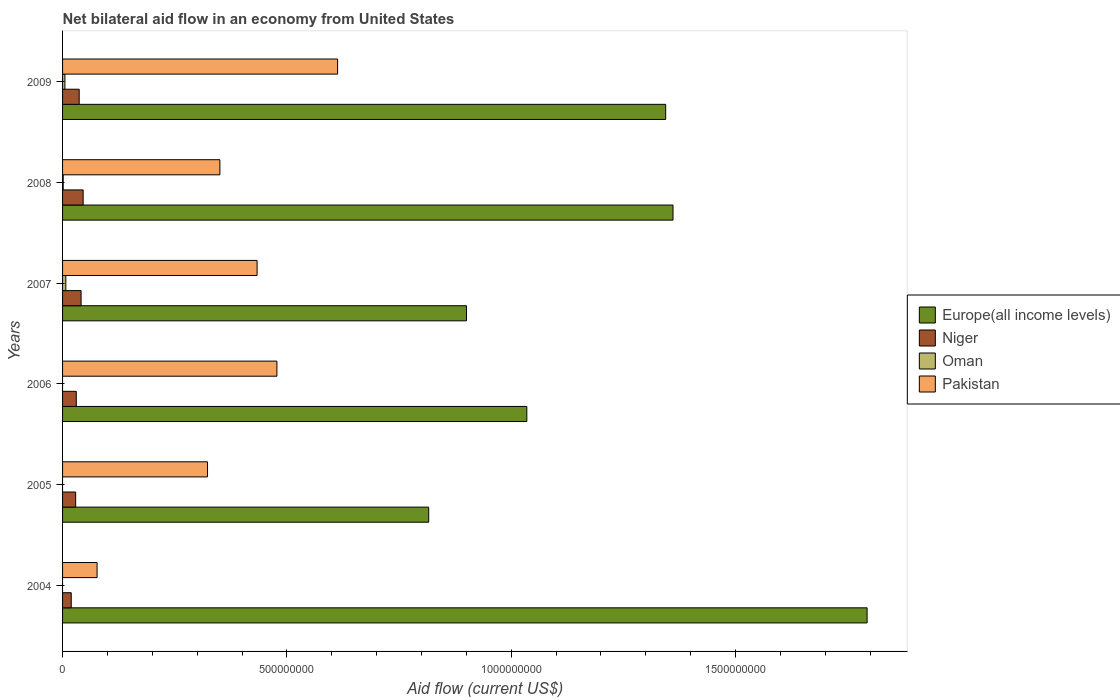How many different coloured bars are there?
Give a very brief answer. 4. How many groups of bars are there?
Provide a succinct answer. 6. Are the number of bars per tick equal to the number of legend labels?
Ensure brevity in your answer.  No. Are the number of bars on each tick of the Y-axis equal?
Make the answer very short. No. What is the label of the 4th group of bars from the top?
Your answer should be compact. 2006. What is the net bilateral aid flow in Oman in 2005?
Offer a very short reply. 0. Across all years, what is the maximum net bilateral aid flow in Niger?
Provide a succinct answer. 4.59e+07. What is the total net bilateral aid flow in Pakistan in the graph?
Give a very brief answer. 2.27e+09. What is the difference between the net bilateral aid flow in Niger in 2006 and that in 2008?
Provide a succinct answer. -1.53e+07. What is the difference between the net bilateral aid flow in Niger in 2006 and the net bilateral aid flow in Pakistan in 2007?
Offer a terse response. -4.03e+08. What is the average net bilateral aid flow in Europe(all income levels) per year?
Make the answer very short. 1.21e+09. In the year 2009, what is the difference between the net bilateral aid flow in Oman and net bilateral aid flow in Pakistan?
Offer a very short reply. -6.08e+08. In how many years, is the net bilateral aid flow in Pakistan greater than 300000000 US$?
Your response must be concise. 5. What is the ratio of the net bilateral aid flow in Niger in 2006 to that in 2009?
Your answer should be compact. 0.82. Is the net bilateral aid flow in Pakistan in 2004 less than that in 2009?
Keep it short and to the point. Yes. Is the difference between the net bilateral aid flow in Oman in 2007 and 2009 greater than the difference between the net bilateral aid flow in Pakistan in 2007 and 2009?
Your response must be concise. Yes. What is the difference between the highest and the second highest net bilateral aid flow in Niger?
Keep it short and to the point. 4.58e+06. What is the difference between the highest and the lowest net bilateral aid flow in Oman?
Make the answer very short. 7.27e+06. Is the sum of the net bilateral aid flow in Niger in 2006 and 2007 greater than the maximum net bilateral aid flow in Europe(all income levels) across all years?
Your answer should be very brief. No. Is it the case that in every year, the sum of the net bilateral aid flow in Europe(all income levels) and net bilateral aid flow in Oman is greater than the sum of net bilateral aid flow in Pakistan and net bilateral aid flow in Niger?
Your answer should be very brief. No. Are all the bars in the graph horizontal?
Ensure brevity in your answer.  Yes. How many years are there in the graph?
Provide a succinct answer. 6. Does the graph contain any zero values?
Make the answer very short. Yes. Does the graph contain grids?
Give a very brief answer. No. How many legend labels are there?
Provide a succinct answer. 4. What is the title of the graph?
Provide a short and direct response. Net bilateral aid flow in an economy from United States. What is the label or title of the Y-axis?
Provide a succinct answer. Years. What is the Aid flow (current US$) in Europe(all income levels) in 2004?
Give a very brief answer. 1.79e+09. What is the Aid flow (current US$) of Niger in 2004?
Your answer should be very brief. 1.93e+07. What is the Aid flow (current US$) of Pakistan in 2004?
Your response must be concise. 7.69e+07. What is the Aid flow (current US$) in Europe(all income levels) in 2005?
Your response must be concise. 8.16e+08. What is the Aid flow (current US$) of Niger in 2005?
Ensure brevity in your answer.  2.92e+07. What is the Aid flow (current US$) in Oman in 2005?
Keep it short and to the point. 0. What is the Aid flow (current US$) of Pakistan in 2005?
Provide a short and direct response. 3.23e+08. What is the Aid flow (current US$) in Europe(all income levels) in 2006?
Offer a terse response. 1.03e+09. What is the Aid flow (current US$) in Niger in 2006?
Offer a terse response. 3.06e+07. What is the Aid flow (current US$) in Oman in 2006?
Keep it short and to the point. 0. What is the Aid flow (current US$) in Pakistan in 2006?
Your response must be concise. 4.78e+08. What is the Aid flow (current US$) of Europe(all income levels) in 2007?
Your response must be concise. 9.00e+08. What is the Aid flow (current US$) in Niger in 2007?
Give a very brief answer. 4.13e+07. What is the Aid flow (current US$) of Oman in 2007?
Provide a short and direct response. 7.27e+06. What is the Aid flow (current US$) in Pakistan in 2007?
Provide a succinct answer. 4.34e+08. What is the Aid flow (current US$) in Europe(all income levels) in 2008?
Ensure brevity in your answer.  1.36e+09. What is the Aid flow (current US$) of Niger in 2008?
Your response must be concise. 4.59e+07. What is the Aid flow (current US$) in Oman in 2008?
Offer a very short reply. 1.43e+06. What is the Aid flow (current US$) in Pakistan in 2008?
Your answer should be compact. 3.51e+08. What is the Aid flow (current US$) of Europe(all income levels) in 2009?
Your answer should be very brief. 1.34e+09. What is the Aid flow (current US$) in Niger in 2009?
Provide a short and direct response. 3.70e+07. What is the Aid flow (current US$) in Oman in 2009?
Offer a terse response. 5.25e+06. What is the Aid flow (current US$) in Pakistan in 2009?
Ensure brevity in your answer.  6.13e+08. Across all years, what is the maximum Aid flow (current US$) of Europe(all income levels)?
Offer a very short reply. 1.79e+09. Across all years, what is the maximum Aid flow (current US$) of Niger?
Provide a short and direct response. 4.59e+07. Across all years, what is the maximum Aid flow (current US$) of Oman?
Provide a short and direct response. 7.27e+06. Across all years, what is the maximum Aid flow (current US$) of Pakistan?
Give a very brief answer. 6.13e+08. Across all years, what is the minimum Aid flow (current US$) of Europe(all income levels)?
Make the answer very short. 8.16e+08. Across all years, what is the minimum Aid flow (current US$) of Niger?
Make the answer very short. 1.93e+07. Across all years, what is the minimum Aid flow (current US$) in Oman?
Offer a terse response. 0. Across all years, what is the minimum Aid flow (current US$) in Pakistan?
Keep it short and to the point. 7.69e+07. What is the total Aid flow (current US$) in Europe(all income levels) in the graph?
Give a very brief answer. 7.25e+09. What is the total Aid flow (current US$) in Niger in the graph?
Provide a succinct answer. 2.03e+08. What is the total Aid flow (current US$) of Oman in the graph?
Your answer should be very brief. 1.40e+07. What is the total Aid flow (current US$) in Pakistan in the graph?
Provide a short and direct response. 2.27e+09. What is the difference between the Aid flow (current US$) in Europe(all income levels) in 2004 and that in 2005?
Your answer should be compact. 9.77e+08. What is the difference between the Aid flow (current US$) of Niger in 2004 and that in 2005?
Offer a terse response. -9.88e+06. What is the difference between the Aid flow (current US$) in Pakistan in 2004 and that in 2005?
Provide a succinct answer. -2.46e+08. What is the difference between the Aid flow (current US$) in Europe(all income levels) in 2004 and that in 2006?
Offer a very short reply. 7.58e+08. What is the difference between the Aid flow (current US$) of Niger in 2004 and that in 2006?
Give a very brief answer. -1.12e+07. What is the difference between the Aid flow (current US$) of Pakistan in 2004 and that in 2006?
Provide a short and direct response. -4.01e+08. What is the difference between the Aid flow (current US$) of Europe(all income levels) in 2004 and that in 2007?
Your answer should be very brief. 8.93e+08. What is the difference between the Aid flow (current US$) in Niger in 2004 and that in 2007?
Provide a succinct answer. -2.20e+07. What is the difference between the Aid flow (current US$) in Pakistan in 2004 and that in 2007?
Offer a very short reply. -3.57e+08. What is the difference between the Aid flow (current US$) in Europe(all income levels) in 2004 and that in 2008?
Give a very brief answer. 4.33e+08. What is the difference between the Aid flow (current US$) of Niger in 2004 and that in 2008?
Offer a very short reply. -2.65e+07. What is the difference between the Aid flow (current US$) in Pakistan in 2004 and that in 2008?
Keep it short and to the point. -2.74e+08. What is the difference between the Aid flow (current US$) in Europe(all income levels) in 2004 and that in 2009?
Your response must be concise. 4.49e+08. What is the difference between the Aid flow (current US$) in Niger in 2004 and that in 2009?
Offer a terse response. -1.77e+07. What is the difference between the Aid flow (current US$) in Pakistan in 2004 and that in 2009?
Give a very brief answer. -5.36e+08. What is the difference between the Aid flow (current US$) in Europe(all income levels) in 2005 and that in 2006?
Your answer should be compact. -2.19e+08. What is the difference between the Aid flow (current US$) of Niger in 2005 and that in 2006?
Provide a short and direct response. -1.36e+06. What is the difference between the Aid flow (current US$) of Pakistan in 2005 and that in 2006?
Make the answer very short. -1.55e+08. What is the difference between the Aid flow (current US$) in Europe(all income levels) in 2005 and that in 2007?
Keep it short and to the point. -8.42e+07. What is the difference between the Aid flow (current US$) of Niger in 2005 and that in 2007?
Your answer should be compact. -1.21e+07. What is the difference between the Aid flow (current US$) of Pakistan in 2005 and that in 2007?
Keep it short and to the point. -1.10e+08. What is the difference between the Aid flow (current US$) of Europe(all income levels) in 2005 and that in 2008?
Give a very brief answer. -5.45e+08. What is the difference between the Aid flow (current US$) of Niger in 2005 and that in 2008?
Provide a short and direct response. -1.67e+07. What is the difference between the Aid flow (current US$) of Pakistan in 2005 and that in 2008?
Your answer should be compact. -2.76e+07. What is the difference between the Aid flow (current US$) of Europe(all income levels) in 2005 and that in 2009?
Your answer should be very brief. -5.28e+08. What is the difference between the Aid flow (current US$) in Niger in 2005 and that in 2009?
Provide a short and direct response. -7.85e+06. What is the difference between the Aid flow (current US$) in Pakistan in 2005 and that in 2009?
Offer a terse response. -2.90e+08. What is the difference between the Aid flow (current US$) of Europe(all income levels) in 2006 and that in 2007?
Give a very brief answer. 1.34e+08. What is the difference between the Aid flow (current US$) in Niger in 2006 and that in 2007?
Your answer should be very brief. -1.07e+07. What is the difference between the Aid flow (current US$) in Pakistan in 2006 and that in 2007?
Your response must be concise. 4.42e+07. What is the difference between the Aid flow (current US$) in Europe(all income levels) in 2006 and that in 2008?
Your response must be concise. -3.26e+08. What is the difference between the Aid flow (current US$) in Niger in 2006 and that in 2008?
Give a very brief answer. -1.53e+07. What is the difference between the Aid flow (current US$) in Pakistan in 2006 and that in 2008?
Make the answer very short. 1.27e+08. What is the difference between the Aid flow (current US$) in Europe(all income levels) in 2006 and that in 2009?
Ensure brevity in your answer.  -3.10e+08. What is the difference between the Aid flow (current US$) of Niger in 2006 and that in 2009?
Make the answer very short. -6.49e+06. What is the difference between the Aid flow (current US$) of Pakistan in 2006 and that in 2009?
Give a very brief answer. -1.35e+08. What is the difference between the Aid flow (current US$) of Europe(all income levels) in 2007 and that in 2008?
Your response must be concise. -4.60e+08. What is the difference between the Aid flow (current US$) of Niger in 2007 and that in 2008?
Offer a terse response. -4.58e+06. What is the difference between the Aid flow (current US$) in Oman in 2007 and that in 2008?
Keep it short and to the point. 5.84e+06. What is the difference between the Aid flow (current US$) of Pakistan in 2007 and that in 2008?
Your answer should be very brief. 8.29e+07. What is the difference between the Aid flow (current US$) in Europe(all income levels) in 2007 and that in 2009?
Offer a very short reply. -4.44e+08. What is the difference between the Aid flow (current US$) in Niger in 2007 and that in 2009?
Offer a very short reply. 4.23e+06. What is the difference between the Aid flow (current US$) in Oman in 2007 and that in 2009?
Your response must be concise. 2.02e+06. What is the difference between the Aid flow (current US$) of Pakistan in 2007 and that in 2009?
Give a very brief answer. -1.79e+08. What is the difference between the Aid flow (current US$) of Europe(all income levels) in 2008 and that in 2009?
Ensure brevity in your answer.  1.63e+07. What is the difference between the Aid flow (current US$) of Niger in 2008 and that in 2009?
Make the answer very short. 8.81e+06. What is the difference between the Aid flow (current US$) of Oman in 2008 and that in 2009?
Offer a very short reply. -3.82e+06. What is the difference between the Aid flow (current US$) of Pakistan in 2008 and that in 2009?
Offer a very short reply. -2.62e+08. What is the difference between the Aid flow (current US$) of Europe(all income levels) in 2004 and the Aid flow (current US$) of Niger in 2005?
Make the answer very short. 1.76e+09. What is the difference between the Aid flow (current US$) of Europe(all income levels) in 2004 and the Aid flow (current US$) of Pakistan in 2005?
Ensure brevity in your answer.  1.47e+09. What is the difference between the Aid flow (current US$) of Niger in 2004 and the Aid flow (current US$) of Pakistan in 2005?
Offer a very short reply. -3.04e+08. What is the difference between the Aid flow (current US$) of Europe(all income levels) in 2004 and the Aid flow (current US$) of Niger in 2006?
Your answer should be compact. 1.76e+09. What is the difference between the Aid flow (current US$) in Europe(all income levels) in 2004 and the Aid flow (current US$) in Pakistan in 2006?
Offer a very short reply. 1.32e+09. What is the difference between the Aid flow (current US$) in Niger in 2004 and the Aid flow (current US$) in Pakistan in 2006?
Give a very brief answer. -4.58e+08. What is the difference between the Aid flow (current US$) in Europe(all income levels) in 2004 and the Aid flow (current US$) in Niger in 2007?
Your answer should be very brief. 1.75e+09. What is the difference between the Aid flow (current US$) in Europe(all income levels) in 2004 and the Aid flow (current US$) in Oman in 2007?
Make the answer very short. 1.79e+09. What is the difference between the Aid flow (current US$) in Europe(all income levels) in 2004 and the Aid flow (current US$) in Pakistan in 2007?
Provide a short and direct response. 1.36e+09. What is the difference between the Aid flow (current US$) in Niger in 2004 and the Aid flow (current US$) in Oman in 2007?
Your answer should be very brief. 1.20e+07. What is the difference between the Aid flow (current US$) in Niger in 2004 and the Aid flow (current US$) in Pakistan in 2007?
Make the answer very short. -4.14e+08. What is the difference between the Aid flow (current US$) of Europe(all income levels) in 2004 and the Aid flow (current US$) of Niger in 2008?
Offer a terse response. 1.75e+09. What is the difference between the Aid flow (current US$) of Europe(all income levels) in 2004 and the Aid flow (current US$) of Oman in 2008?
Offer a terse response. 1.79e+09. What is the difference between the Aid flow (current US$) in Europe(all income levels) in 2004 and the Aid flow (current US$) in Pakistan in 2008?
Ensure brevity in your answer.  1.44e+09. What is the difference between the Aid flow (current US$) in Niger in 2004 and the Aid flow (current US$) in Oman in 2008?
Ensure brevity in your answer.  1.79e+07. What is the difference between the Aid flow (current US$) in Niger in 2004 and the Aid flow (current US$) in Pakistan in 2008?
Keep it short and to the point. -3.31e+08. What is the difference between the Aid flow (current US$) of Europe(all income levels) in 2004 and the Aid flow (current US$) of Niger in 2009?
Offer a very short reply. 1.76e+09. What is the difference between the Aid flow (current US$) of Europe(all income levels) in 2004 and the Aid flow (current US$) of Oman in 2009?
Offer a very short reply. 1.79e+09. What is the difference between the Aid flow (current US$) in Europe(all income levels) in 2004 and the Aid flow (current US$) in Pakistan in 2009?
Keep it short and to the point. 1.18e+09. What is the difference between the Aid flow (current US$) of Niger in 2004 and the Aid flow (current US$) of Oman in 2009?
Offer a terse response. 1.41e+07. What is the difference between the Aid flow (current US$) of Niger in 2004 and the Aid flow (current US$) of Pakistan in 2009?
Keep it short and to the point. -5.94e+08. What is the difference between the Aid flow (current US$) in Europe(all income levels) in 2005 and the Aid flow (current US$) in Niger in 2006?
Give a very brief answer. 7.85e+08. What is the difference between the Aid flow (current US$) in Europe(all income levels) in 2005 and the Aid flow (current US$) in Pakistan in 2006?
Your response must be concise. 3.38e+08. What is the difference between the Aid flow (current US$) of Niger in 2005 and the Aid flow (current US$) of Pakistan in 2006?
Keep it short and to the point. -4.49e+08. What is the difference between the Aid flow (current US$) in Europe(all income levels) in 2005 and the Aid flow (current US$) in Niger in 2007?
Make the answer very short. 7.75e+08. What is the difference between the Aid flow (current US$) in Europe(all income levels) in 2005 and the Aid flow (current US$) in Oman in 2007?
Offer a very short reply. 8.09e+08. What is the difference between the Aid flow (current US$) of Europe(all income levels) in 2005 and the Aid flow (current US$) of Pakistan in 2007?
Your answer should be very brief. 3.82e+08. What is the difference between the Aid flow (current US$) of Niger in 2005 and the Aid flow (current US$) of Oman in 2007?
Provide a short and direct response. 2.19e+07. What is the difference between the Aid flow (current US$) of Niger in 2005 and the Aid flow (current US$) of Pakistan in 2007?
Your answer should be very brief. -4.04e+08. What is the difference between the Aid flow (current US$) of Europe(all income levels) in 2005 and the Aid flow (current US$) of Niger in 2008?
Offer a very short reply. 7.70e+08. What is the difference between the Aid flow (current US$) in Europe(all income levels) in 2005 and the Aid flow (current US$) in Oman in 2008?
Keep it short and to the point. 8.15e+08. What is the difference between the Aid flow (current US$) in Europe(all income levels) in 2005 and the Aid flow (current US$) in Pakistan in 2008?
Keep it short and to the point. 4.65e+08. What is the difference between the Aid flow (current US$) in Niger in 2005 and the Aid flow (current US$) in Oman in 2008?
Give a very brief answer. 2.78e+07. What is the difference between the Aid flow (current US$) in Niger in 2005 and the Aid flow (current US$) in Pakistan in 2008?
Ensure brevity in your answer.  -3.21e+08. What is the difference between the Aid flow (current US$) in Europe(all income levels) in 2005 and the Aid flow (current US$) in Niger in 2009?
Offer a terse response. 7.79e+08. What is the difference between the Aid flow (current US$) in Europe(all income levels) in 2005 and the Aid flow (current US$) in Oman in 2009?
Provide a short and direct response. 8.11e+08. What is the difference between the Aid flow (current US$) in Europe(all income levels) in 2005 and the Aid flow (current US$) in Pakistan in 2009?
Make the answer very short. 2.03e+08. What is the difference between the Aid flow (current US$) of Niger in 2005 and the Aid flow (current US$) of Oman in 2009?
Your answer should be compact. 2.40e+07. What is the difference between the Aid flow (current US$) in Niger in 2005 and the Aid flow (current US$) in Pakistan in 2009?
Offer a terse response. -5.84e+08. What is the difference between the Aid flow (current US$) of Europe(all income levels) in 2006 and the Aid flow (current US$) of Niger in 2007?
Offer a terse response. 9.93e+08. What is the difference between the Aid flow (current US$) of Europe(all income levels) in 2006 and the Aid flow (current US$) of Oman in 2007?
Your answer should be compact. 1.03e+09. What is the difference between the Aid flow (current US$) in Europe(all income levels) in 2006 and the Aid flow (current US$) in Pakistan in 2007?
Give a very brief answer. 6.01e+08. What is the difference between the Aid flow (current US$) in Niger in 2006 and the Aid flow (current US$) in Oman in 2007?
Keep it short and to the point. 2.33e+07. What is the difference between the Aid flow (current US$) in Niger in 2006 and the Aid flow (current US$) in Pakistan in 2007?
Your answer should be very brief. -4.03e+08. What is the difference between the Aid flow (current US$) in Europe(all income levels) in 2006 and the Aid flow (current US$) in Niger in 2008?
Keep it short and to the point. 9.89e+08. What is the difference between the Aid flow (current US$) of Europe(all income levels) in 2006 and the Aid flow (current US$) of Oman in 2008?
Your response must be concise. 1.03e+09. What is the difference between the Aid flow (current US$) of Europe(all income levels) in 2006 and the Aid flow (current US$) of Pakistan in 2008?
Provide a succinct answer. 6.84e+08. What is the difference between the Aid flow (current US$) in Niger in 2006 and the Aid flow (current US$) in Oman in 2008?
Offer a very short reply. 2.91e+07. What is the difference between the Aid flow (current US$) of Niger in 2006 and the Aid flow (current US$) of Pakistan in 2008?
Give a very brief answer. -3.20e+08. What is the difference between the Aid flow (current US$) in Europe(all income levels) in 2006 and the Aid flow (current US$) in Niger in 2009?
Your answer should be very brief. 9.98e+08. What is the difference between the Aid flow (current US$) of Europe(all income levels) in 2006 and the Aid flow (current US$) of Oman in 2009?
Your answer should be very brief. 1.03e+09. What is the difference between the Aid flow (current US$) in Europe(all income levels) in 2006 and the Aid flow (current US$) in Pakistan in 2009?
Offer a terse response. 4.22e+08. What is the difference between the Aid flow (current US$) in Niger in 2006 and the Aid flow (current US$) in Oman in 2009?
Your answer should be compact. 2.53e+07. What is the difference between the Aid flow (current US$) of Niger in 2006 and the Aid flow (current US$) of Pakistan in 2009?
Make the answer very short. -5.82e+08. What is the difference between the Aid flow (current US$) in Europe(all income levels) in 2007 and the Aid flow (current US$) in Niger in 2008?
Your response must be concise. 8.54e+08. What is the difference between the Aid flow (current US$) of Europe(all income levels) in 2007 and the Aid flow (current US$) of Oman in 2008?
Offer a terse response. 8.99e+08. What is the difference between the Aid flow (current US$) in Europe(all income levels) in 2007 and the Aid flow (current US$) in Pakistan in 2008?
Offer a very short reply. 5.50e+08. What is the difference between the Aid flow (current US$) in Niger in 2007 and the Aid flow (current US$) in Oman in 2008?
Provide a short and direct response. 3.98e+07. What is the difference between the Aid flow (current US$) of Niger in 2007 and the Aid flow (current US$) of Pakistan in 2008?
Keep it short and to the point. -3.09e+08. What is the difference between the Aid flow (current US$) of Oman in 2007 and the Aid flow (current US$) of Pakistan in 2008?
Give a very brief answer. -3.43e+08. What is the difference between the Aid flow (current US$) in Europe(all income levels) in 2007 and the Aid flow (current US$) in Niger in 2009?
Make the answer very short. 8.63e+08. What is the difference between the Aid flow (current US$) in Europe(all income levels) in 2007 and the Aid flow (current US$) in Oman in 2009?
Offer a terse response. 8.95e+08. What is the difference between the Aid flow (current US$) of Europe(all income levels) in 2007 and the Aid flow (current US$) of Pakistan in 2009?
Keep it short and to the point. 2.87e+08. What is the difference between the Aid flow (current US$) of Niger in 2007 and the Aid flow (current US$) of Oman in 2009?
Offer a very short reply. 3.60e+07. What is the difference between the Aid flow (current US$) of Niger in 2007 and the Aid flow (current US$) of Pakistan in 2009?
Make the answer very short. -5.72e+08. What is the difference between the Aid flow (current US$) in Oman in 2007 and the Aid flow (current US$) in Pakistan in 2009?
Ensure brevity in your answer.  -6.06e+08. What is the difference between the Aid flow (current US$) in Europe(all income levels) in 2008 and the Aid flow (current US$) in Niger in 2009?
Keep it short and to the point. 1.32e+09. What is the difference between the Aid flow (current US$) in Europe(all income levels) in 2008 and the Aid flow (current US$) in Oman in 2009?
Give a very brief answer. 1.36e+09. What is the difference between the Aid flow (current US$) of Europe(all income levels) in 2008 and the Aid flow (current US$) of Pakistan in 2009?
Your answer should be compact. 7.48e+08. What is the difference between the Aid flow (current US$) of Niger in 2008 and the Aid flow (current US$) of Oman in 2009?
Your answer should be very brief. 4.06e+07. What is the difference between the Aid flow (current US$) of Niger in 2008 and the Aid flow (current US$) of Pakistan in 2009?
Ensure brevity in your answer.  -5.67e+08. What is the difference between the Aid flow (current US$) of Oman in 2008 and the Aid flow (current US$) of Pakistan in 2009?
Keep it short and to the point. -6.12e+08. What is the average Aid flow (current US$) of Europe(all income levels) per year?
Your answer should be very brief. 1.21e+09. What is the average Aid flow (current US$) in Niger per year?
Make the answer very short. 3.39e+07. What is the average Aid flow (current US$) of Oman per year?
Give a very brief answer. 2.32e+06. What is the average Aid flow (current US$) of Pakistan per year?
Offer a very short reply. 3.79e+08. In the year 2004, what is the difference between the Aid flow (current US$) in Europe(all income levels) and Aid flow (current US$) in Niger?
Make the answer very short. 1.77e+09. In the year 2004, what is the difference between the Aid flow (current US$) in Europe(all income levels) and Aid flow (current US$) in Pakistan?
Your response must be concise. 1.72e+09. In the year 2004, what is the difference between the Aid flow (current US$) in Niger and Aid flow (current US$) in Pakistan?
Ensure brevity in your answer.  -5.76e+07. In the year 2005, what is the difference between the Aid flow (current US$) in Europe(all income levels) and Aid flow (current US$) in Niger?
Your answer should be very brief. 7.87e+08. In the year 2005, what is the difference between the Aid flow (current US$) of Europe(all income levels) and Aid flow (current US$) of Pakistan?
Your answer should be very brief. 4.93e+08. In the year 2005, what is the difference between the Aid flow (current US$) in Niger and Aid flow (current US$) in Pakistan?
Offer a terse response. -2.94e+08. In the year 2006, what is the difference between the Aid flow (current US$) of Europe(all income levels) and Aid flow (current US$) of Niger?
Offer a very short reply. 1.00e+09. In the year 2006, what is the difference between the Aid flow (current US$) of Europe(all income levels) and Aid flow (current US$) of Pakistan?
Ensure brevity in your answer.  5.57e+08. In the year 2006, what is the difference between the Aid flow (current US$) of Niger and Aid flow (current US$) of Pakistan?
Provide a short and direct response. -4.47e+08. In the year 2007, what is the difference between the Aid flow (current US$) in Europe(all income levels) and Aid flow (current US$) in Niger?
Ensure brevity in your answer.  8.59e+08. In the year 2007, what is the difference between the Aid flow (current US$) of Europe(all income levels) and Aid flow (current US$) of Oman?
Keep it short and to the point. 8.93e+08. In the year 2007, what is the difference between the Aid flow (current US$) in Europe(all income levels) and Aid flow (current US$) in Pakistan?
Keep it short and to the point. 4.67e+08. In the year 2007, what is the difference between the Aid flow (current US$) of Niger and Aid flow (current US$) of Oman?
Make the answer very short. 3.40e+07. In the year 2007, what is the difference between the Aid flow (current US$) of Niger and Aid flow (current US$) of Pakistan?
Your answer should be compact. -3.92e+08. In the year 2007, what is the difference between the Aid flow (current US$) of Oman and Aid flow (current US$) of Pakistan?
Provide a succinct answer. -4.26e+08. In the year 2008, what is the difference between the Aid flow (current US$) of Europe(all income levels) and Aid flow (current US$) of Niger?
Your response must be concise. 1.31e+09. In the year 2008, what is the difference between the Aid flow (current US$) in Europe(all income levels) and Aid flow (current US$) in Oman?
Your response must be concise. 1.36e+09. In the year 2008, what is the difference between the Aid flow (current US$) in Europe(all income levels) and Aid flow (current US$) in Pakistan?
Your answer should be compact. 1.01e+09. In the year 2008, what is the difference between the Aid flow (current US$) of Niger and Aid flow (current US$) of Oman?
Your answer should be very brief. 4.44e+07. In the year 2008, what is the difference between the Aid flow (current US$) of Niger and Aid flow (current US$) of Pakistan?
Your response must be concise. -3.05e+08. In the year 2008, what is the difference between the Aid flow (current US$) of Oman and Aid flow (current US$) of Pakistan?
Provide a succinct answer. -3.49e+08. In the year 2009, what is the difference between the Aid flow (current US$) in Europe(all income levels) and Aid flow (current US$) in Niger?
Make the answer very short. 1.31e+09. In the year 2009, what is the difference between the Aid flow (current US$) in Europe(all income levels) and Aid flow (current US$) in Oman?
Ensure brevity in your answer.  1.34e+09. In the year 2009, what is the difference between the Aid flow (current US$) in Europe(all income levels) and Aid flow (current US$) in Pakistan?
Provide a short and direct response. 7.31e+08. In the year 2009, what is the difference between the Aid flow (current US$) in Niger and Aid flow (current US$) in Oman?
Offer a terse response. 3.18e+07. In the year 2009, what is the difference between the Aid flow (current US$) in Niger and Aid flow (current US$) in Pakistan?
Offer a very short reply. -5.76e+08. In the year 2009, what is the difference between the Aid flow (current US$) in Oman and Aid flow (current US$) in Pakistan?
Provide a short and direct response. -6.08e+08. What is the ratio of the Aid flow (current US$) of Europe(all income levels) in 2004 to that in 2005?
Offer a terse response. 2.2. What is the ratio of the Aid flow (current US$) in Niger in 2004 to that in 2005?
Give a very brief answer. 0.66. What is the ratio of the Aid flow (current US$) in Pakistan in 2004 to that in 2005?
Your response must be concise. 0.24. What is the ratio of the Aid flow (current US$) in Europe(all income levels) in 2004 to that in 2006?
Keep it short and to the point. 1.73. What is the ratio of the Aid flow (current US$) in Niger in 2004 to that in 2006?
Make the answer very short. 0.63. What is the ratio of the Aid flow (current US$) of Pakistan in 2004 to that in 2006?
Provide a short and direct response. 0.16. What is the ratio of the Aid flow (current US$) in Europe(all income levels) in 2004 to that in 2007?
Your answer should be very brief. 1.99. What is the ratio of the Aid flow (current US$) of Niger in 2004 to that in 2007?
Your answer should be very brief. 0.47. What is the ratio of the Aid flow (current US$) in Pakistan in 2004 to that in 2007?
Your response must be concise. 0.18. What is the ratio of the Aid flow (current US$) of Europe(all income levels) in 2004 to that in 2008?
Give a very brief answer. 1.32. What is the ratio of the Aid flow (current US$) in Niger in 2004 to that in 2008?
Make the answer very short. 0.42. What is the ratio of the Aid flow (current US$) in Pakistan in 2004 to that in 2008?
Give a very brief answer. 0.22. What is the ratio of the Aid flow (current US$) in Europe(all income levels) in 2004 to that in 2009?
Give a very brief answer. 1.33. What is the ratio of the Aid flow (current US$) of Niger in 2004 to that in 2009?
Keep it short and to the point. 0.52. What is the ratio of the Aid flow (current US$) in Pakistan in 2004 to that in 2009?
Keep it short and to the point. 0.13. What is the ratio of the Aid flow (current US$) of Europe(all income levels) in 2005 to that in 2006?
Give a very brief answer. 0.79. What is the ratio of the Aid flow (current US$) of Niger in 2005 to that in 2006?
Provide a short and direct response. 0.96. What is the ratio of the Aid flow (current US$) of Pakistan in 2005 to that in 2006?
Ensure brevity in your answer.  0.68. What is the ratio of the Aid flow (current US$) of Europe(all income levels) in 2005 to that in 2007?
Offer a terse response. 0.91. What is the ratio of the Aid flow (current US$) of Niger in 2005 to that in 2007?
Ensure brevity in your answer.  0.71. What is the ratio of the Aid flow (current US$) of Pakistan in 2005 to that in 2007?
Make the answer very short. 0.75. What is the ratio of the Aid flow (current US$) of Europe(all income levels) in 2005 to that in 2008?
Your answer should be compact. 0.6. What is the ratio of the Aid flow (current US$) of Niger in 2005 to that in 2008?
Give a very brief answer. 0.64. What is the ratio of the Aid flow (current US$) in Pakistan in 2005 to that in 2008?
Give a very brief answer. 0.92. What is the ratio of the Aid flow (current US$) of Europe(all income levels) in 2005 to that in 2009?
Offer a terse response. 0.61. What is the ratio of the Aid flow (current US$) in Niger in 2005 to that in 2009?
Your response must be concise. 0.79. What is the ratio of the Aid flow (current US$) of Pakistan in 2005 to that in 2009?
Provide a succinct answer. 0.53. What is the ratio of the Aid flow (current US$) in Europe(all income levels) in 2006 to that in 2007?
Provide a succinct answer. 1.15. What is the ratio of the Aid flow (current US$) of Niger in 2006 to that in 2007?
Your answer should be very brief. 0.74. What is the ratio of the Aid flow (current US$) in Pakistan in 2006 to that in 2007?
Give a very brief answer. 1.1. What is the ratio of the Aid flow (current US$) of Europe(all income levels) in 2006 to that in 2008?
Give a very brief answer. 0.76. What is the ratio of the Aid flow (current US$) of Niger in 2006 to that in 2008?
Offer a terse response. 0.67. What is the ratio of the Aid flow (current US$) in Pakistan in 2006 to that in 2008?
Keep it short and to the point. 1.36. What is the ratio of the Aid flow (current US$) of Europe(all income levels) in 2006 to that in 2009?
Offer a very short reply. 0.77. What is the ratio of the Aid flow (current US$) in Niger in 2006 to that in 2009?
Your answer should be compact. 0.82. What is the ratio of the Aid flow (current US$) in Pakistan in 2006 to that in 2009?
Offer a terse response. 0.78. What is the ratio of the Aid flow (current US$) in Europe(all income levels) in 2007 to that in 2008?
Your response must be concise. 0.66. What is the ratio of the Aid flow (current US$) in Niger in 2007 to that in 2008?
Ensure brevity in your answer.  0.9. What is the ratio of the Aid flow (current US$) in Oman in 2007 to that in 2008?
Give a very brief answer. 5.08. What is the ratio of the Aid flow (current US$) in Pakistan in 2007 to that in 2008?
Your answer should be compact. 1.24. What is the ratio of the Aid flow (current US$) of Europe(all income levels) in 2007 to that in 2009?
Provide a short and direct response. 0.67. What is the ratio of the Aid flow (current US$) in Niger in 2007 to that in 2009?
Your answer should be very brief. 1.11. What is the ratio of the Aid flow (current US$) in Oman in 2007 to that in 2009?
Make the answer very short. 1.38. What is the ratio of the Aid flow (current US$) in Pakistan in 2007 to that in 2009?
Ensure brevity in your answer.  0.71. What is the ratio of the Aid flow (current US$) of Europe(all income levels) in 2008 to that in 2009?
Your answer should be compact. 1.01. What is the ratio of the Aid flow (current US$) in Niger in 2008 to that in 2009?
Provide a succinct answer. 1.24. What is the ratio of the Aid flow (current US$) of Oman in 2008 to that in 2009?
Your answer should be compact. 0.27. What is the ratio of the Aid flow (current US$) of Pakistan in 2008 to that in 2009?
Ensure brevity in your answer.  0.57. What is the difference between the highest and the second highest Aid flow (current US$) of Europe(all income levels)?
Provide a succinct answer. 4.33e+08. What is the difference between the highest and the second highest Aid flow (current US$) of Niger?
Your response must be concise. 4.58e+06. What is the difference between the highest and the second highest Aid flow (current US$) of Oman?
Give a very brief answer. 2.02e+06. What is the difference between the highest and the second highest Aid flow (current US$) in Pakistan?
Ensure brevity in your answer.  1.35e+08. What is the difference between the highest and the lowest Aid flow (current US$) in Europe(all income levels)?
Provide a short and direct response. 9.77e+08. What is the difference between the highest and the lowest Aid flow (current US$) in Niger?
Ensure brevity in your answer.  2.65e+07. What is the difference between the highest and the lowest Aid flow (current US$) of Oman?
Provide a short and direct response. 7.27e+06. What is the difference between the highest and the lowest Aid flow (current US$) in Pakistan?
Your response must be concise. 5.36e+08. 